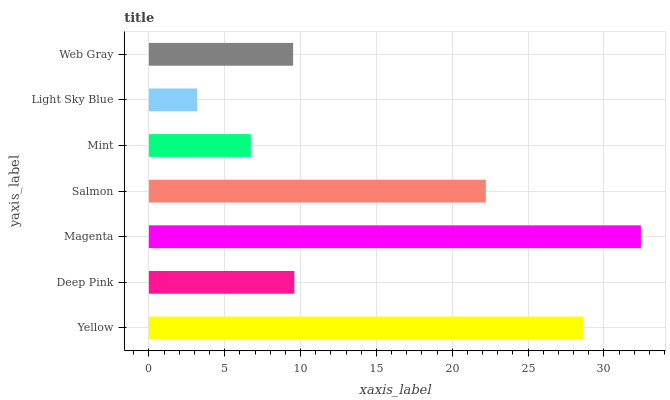Is Light Sky Blue the minimum?
Answer yes or no. Yes. Is Magenta the maximum?
Answer yes or no. Yes. Is Deep Pink the minimum?
Answer yes or no. No. Is Deep Pink the maximum?
Answer yes or no. No. Is Yellow greater than Deep Pink?
Answer yes or no. Yes. Is Deep Pink less than Yellow?
Answer yes or no. Yes. Is Deep Pink greater than Yellow?
Answer yes or no. No. Is Yellow less than Deep Pink?
Answer yes or no. No. Is Deep Pink the high median?
Answer yes or no. Yes. Is Deep Pink the low median?
Answer yes or no. Yes. Is Web Gray the high median?
Answer yes or no. No. Is Light Sky Blue the low median?
Answer yes or no. No. 